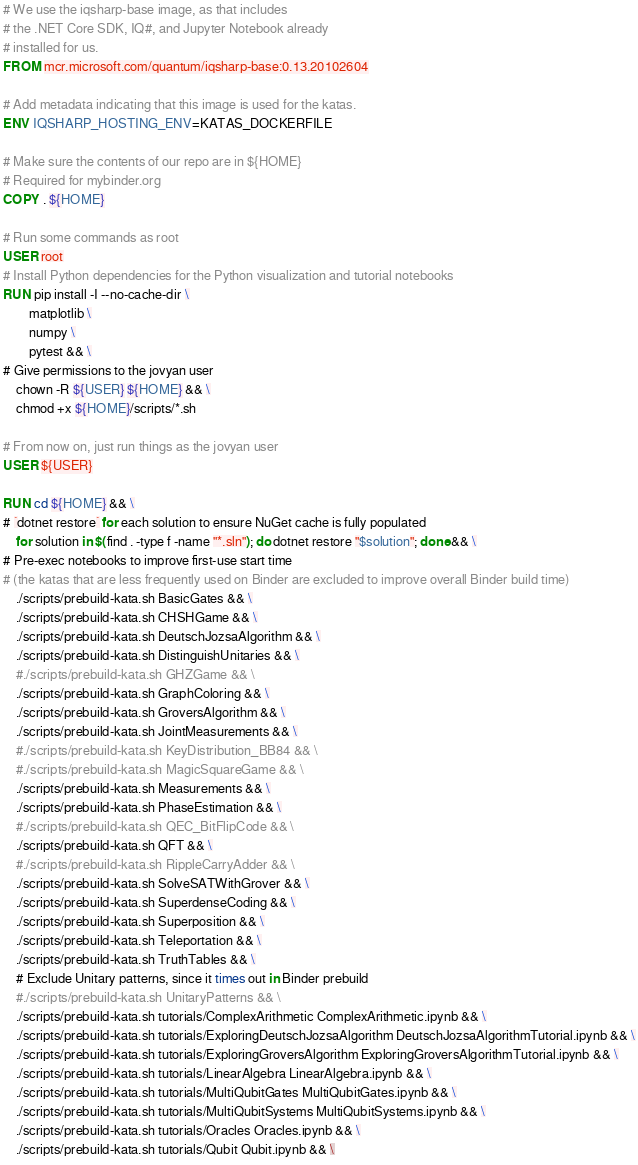Convert code to text. <code><loc_0><loc_0><loc_500><loc_500><_Dockerfile_># We use the iqsharp-base image, as that includes
# the .NET Core SDK, IQ#, and Jupyter Notebook already
# installed for us.
FROM mcr.microsoft.com/quantum/iqsharp-base:0.13.20102604

# Add metadata indicating that this image is used for the katas.
ENV IQSHARP_HOSTING_ENV=KATAS_DOCKERFILE

# Make sure the contents of our repo are in ${HOME}
# Required for mybinder.org
COPY . ${HOME}

# Run some commands as root
USER root
# Install Python dependencies for the Python visualization and tutorial notebooks
RUN pip install -I --no-cache-dir \
        matplotlib \
        numpy \
        pytest && \
# Give permissions to the jovyan user
    chown -R ${USER} ${HOME} && \
    chmod +x ${HOME}/scripts/*.sh

# From now on, just run things as the jovyan user
USER ${USER}

RUN cd ${HOME} && \
# `dotnet restore` for each solution to ensure NuGet cache is fully populated
    for solution in $(find . -type f -name "*.sln"); do dotnet restore "$solution"; done && \
# Pre-exec notebooks to improve first-use start time
# (the katas that are less frequently used on Binder are excluded to improve overall Binder build time)
    ./scripts/prebuild-kata.sh BasicGates && \
    ./scripts/prebuild-kata.sh CHSHGame && \
    ./scripts/prebuild-kata.sh DeutschJozsaAlgorithm && \
    ./scripts/prebuild-kata.sh DistinguishUnitaries && \
    #./scripts/prebuild-kata.sh GHZGame && \
    ./scripts/prebuild-kata.sh GraphColoring && \
    ./scripts/prebuild-kata.sh GroversAlgorithm && \
    ./scripts/prebuild-kata.sh JointMeasurements && \
    #./scripts/prebuild-kata.sh KeyDistribution_BB84 && \
    #./scripts/prebuild-kata.sh MagicSquareGame && \
    ./scripts/prebuild-kata.sh Measurements && \
    ./scripts/prebuild-kata.sh PhaseEstimation && \
    #./scripts/prebuild-kata.sh QEC_BitFlipCode && \
    ./scripts/prebuild-kata.sh QFT && \
    #./scripts/prebuild-kata.sh RippleCarryAdder && \
    ./scripts/prebuild-kata.sh SolveSATWithGrover && \
    ./scripts/prebuild-kata.sh SuperdenseCoding && \
    ./scripts/prebuild-kata.sh Superposition && \
    ./scripts/prebuild-kata.sh Teleportation && \
    ./scripts/prebuild-kata.sh TruthTables && \
    # Exclude Unitary patterns, since it times out in Binder prebuild
    #./scripts/prebuild-kata.sh UnitaryPatterns && \
    ./scripts/prebuild-kata.sh tutorials/ComplexArithmetic ComplexArithmetic.ipynb && \
    ./scripts/prebuild-kata.sh tutorials/ExploringDeutschJozsaAlgorithm DeutschJozsaAlgorithmTutorial.ipynb && \
    ./scripts/prebuild-kata.sh tutorials/ExploringGroversAlgorithm ExploringGroversAlgorithmTutorial.ipynb && \
    ./scripts/prebuild-kata.sh tutorials/LinearAlgebra LinearAlgebra.ipynb && \
    ./scripts/prebuild-kata.sh tutorials/MultiQubitGates MultiQubitGates.ipynb && \
    ./scripts/prebuild-kata.sh tutorials/MultiQubitSystems MultiQubitSystems.ipynb && \
    ./scripts/prebuild-kata.sh tutorials/Oracles Oracles.ipynb && \
    ./scripts/prebuild-kata.sh tutorials/Qubit Qubit.ipynb && \</code> 